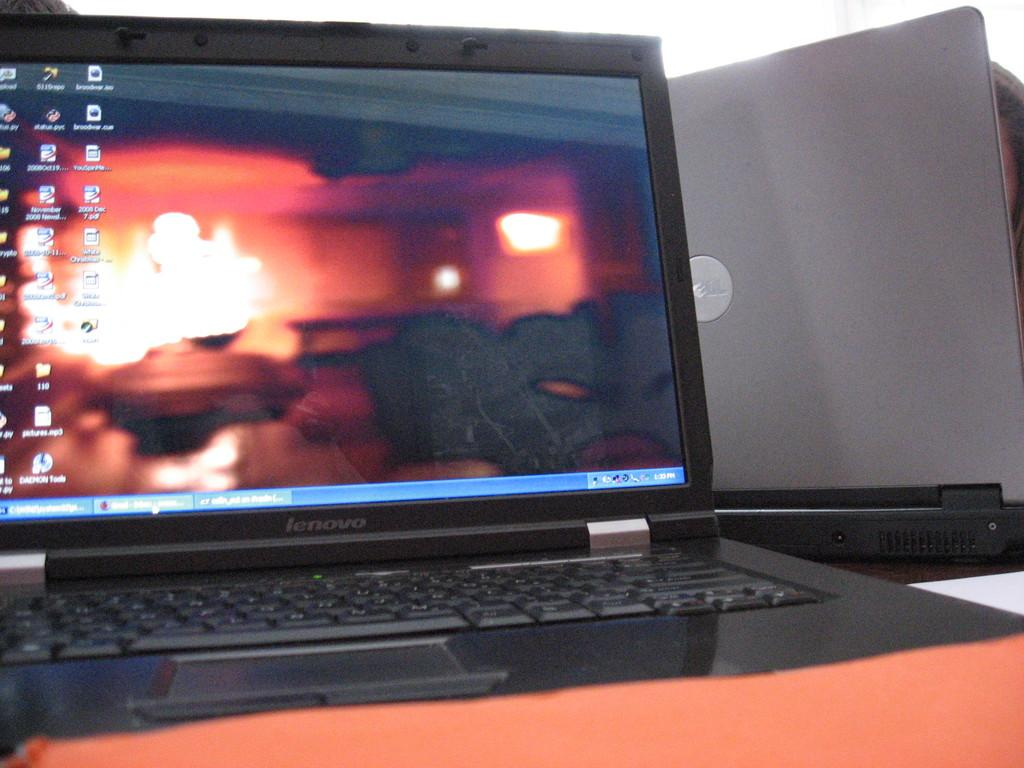<image>
Write a terse but informative summary of the picture. A Lenovo laptop is open and shows several different short cuts for different files on the home screen. 